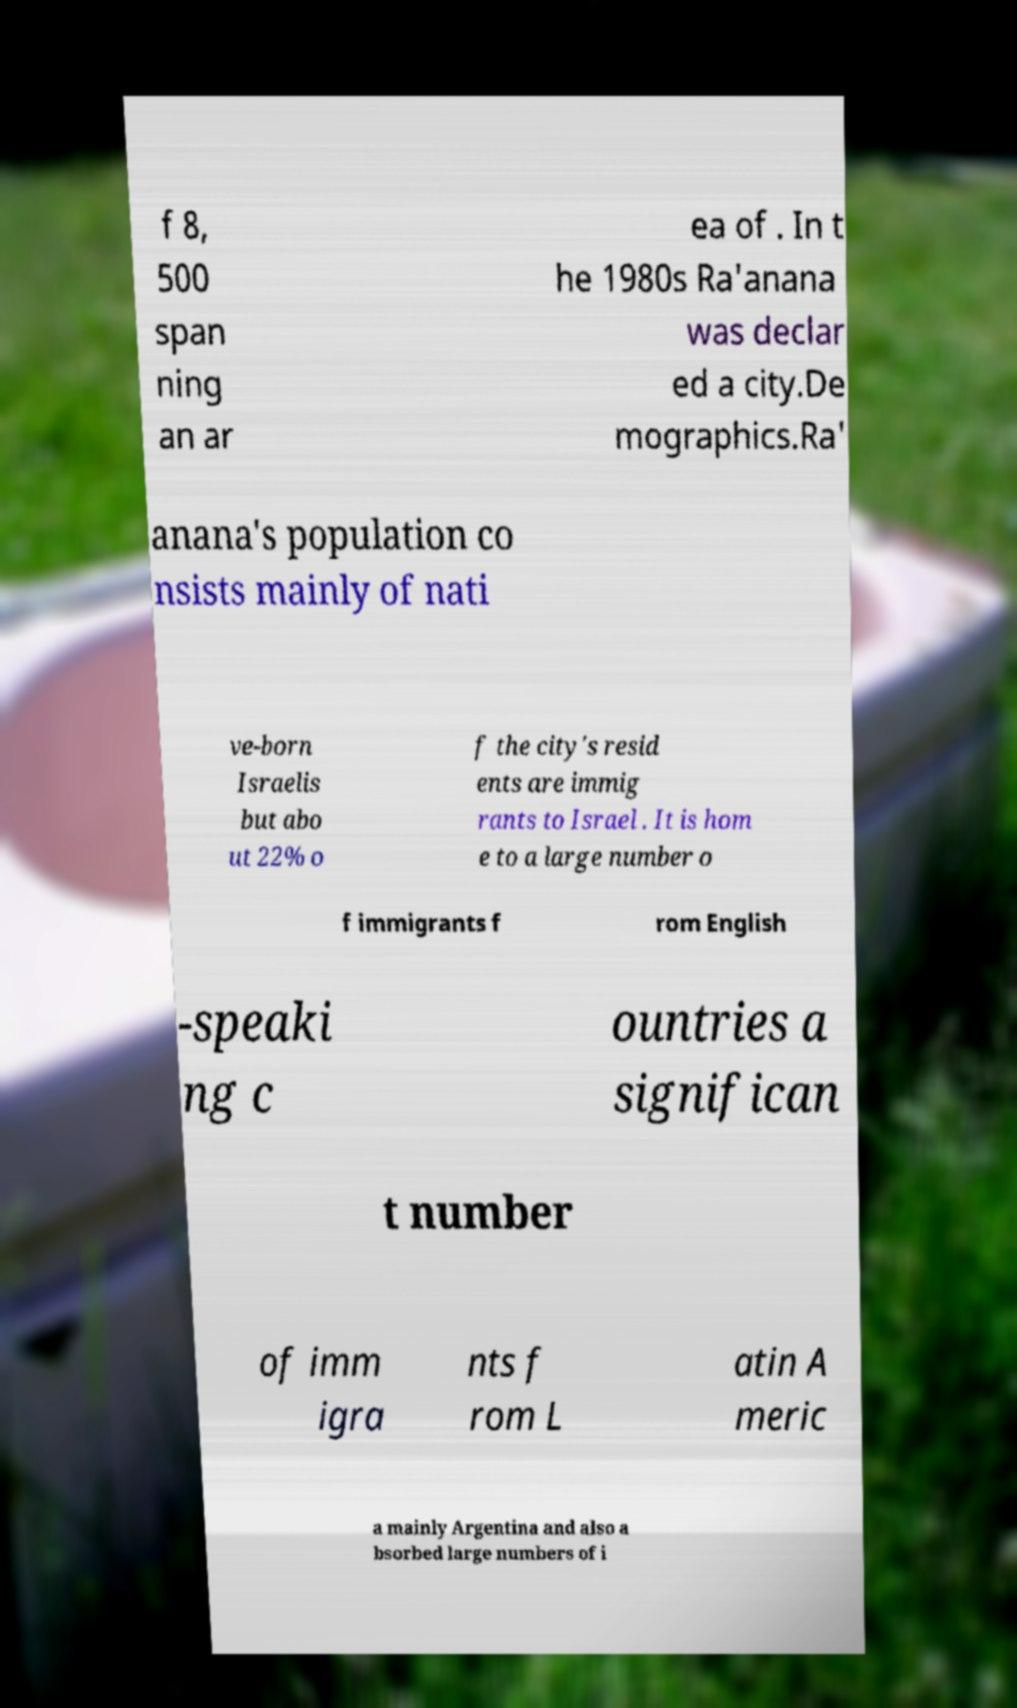Can you accurately transcribe the text from the provided image for me? f 8, 500 span ning an ar ea of . In t he 1980s Ra'anana was declar ed a city.De mographics.Ra' anana's population co nsists mainly of nati ve-born Israelis but abo ut 22% o f the city's resid ents are immig rants to Israel . It is hom e to a large number o f immigrants f rom English -speaki ng c ountries a significan t number of imm igra nts f rom L atin A meric a mainly Argentina and also a bsorbed large numbers of i 